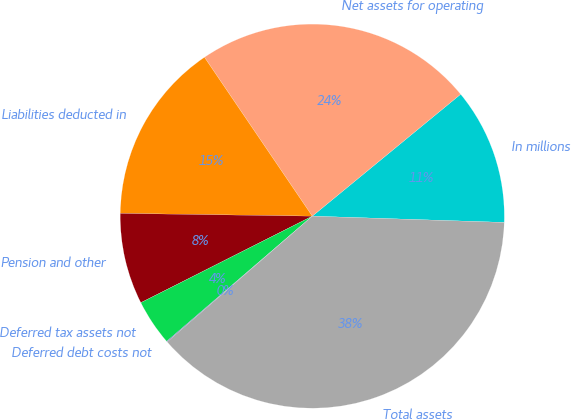<chart> <loc_0><loc_0><loc_500><loc_500><pie_chart><fcel>In millions<fcel>Net assets for operating<fcel>Liabilities deducted in<fcel>Pension and other<fcel>Deferred tax assets not<fcel>Deferred debt costs not<fcel>Total assets<nl><fcel>11.47%<fcel>23.54%<fcel>15.28%<fcel>7.67%<fcel>3.86%<fcel>0.06%<fcel>38.12%<nl></chart> 